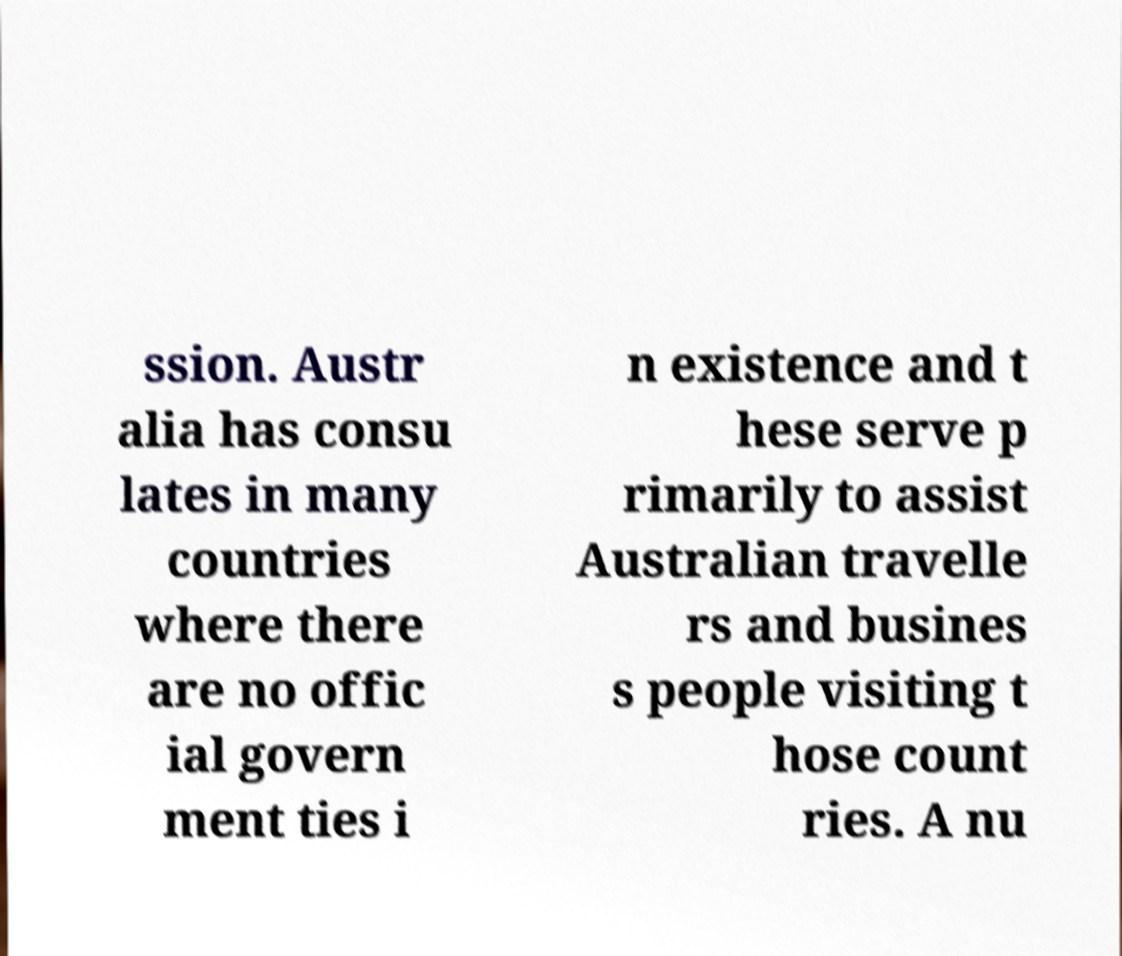Could you extract and type out the text from this image? ssion. Austr alia has consu lates in many countries where there are no offic ial govern ment ties i n existence and t hese serve p rimarily to assist Australian travelle rs and busines s people visiting t hose count ries. A nu 